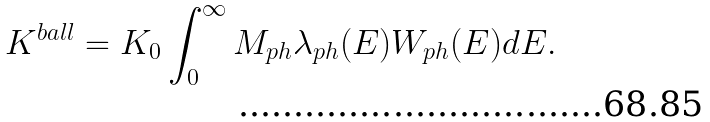<formula> <loc_0><loc_0><loc_500><loc_500>K ^ { b a l l } = K _ { 0 } \int _ { 0 } ^ { \infty } M _ { p h } \lambda _ { p h } ( E ) W _ { p h } ( E ) d E .</formula> 